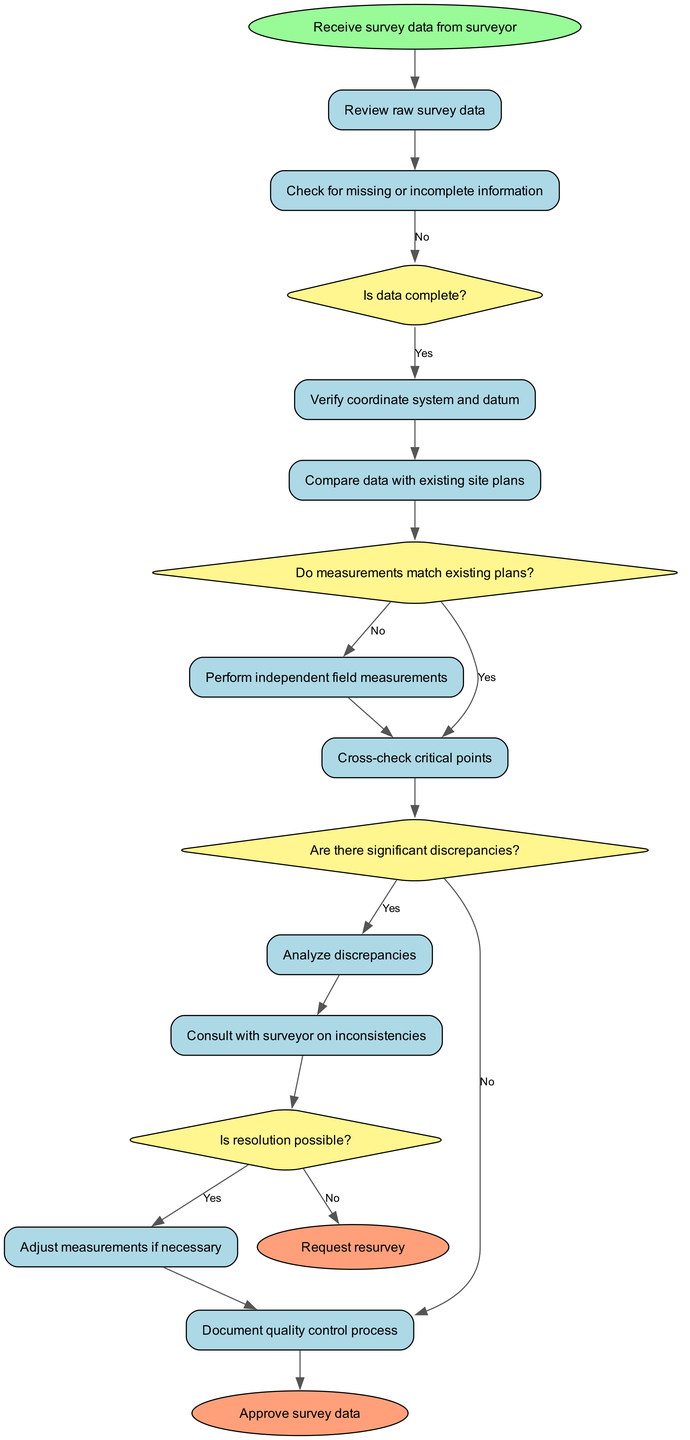What is the first activity after receiving survey data? The first activity listed after the "Receive survey data from surveyor" start node is "Review raw survey data." This is directly connected to the start node, indicating it is the next step in the process.
Answer: Review raw survey data How many decisions are present in the diagram? There are four decision nodes in the diagram: "Is data complete?", "Do measurements match existing plans?", "Are there significant discrepancies?", and "Is resolution possible?". Each of these diamonds represents a decision point.
Answer: 4 What do you do if there are significant discrepancies? If there are significant discrepancies, the flow leads to the "Request resurvey" end node. This indicates that instead of proceeding, the appropriate action is to request a resurvey to address the discrepancies.
Answer: Request resurvey Which activity follows "Analyze discrepancies"? After "Analyze discrepancies", the next activity is "Consult with surveyor on inconsistencies." This direct connection indicates that once discrepancies are analyzed, consultation is required.
Answer: Consult with surveyor on inconsistencies What is the outcome if adjustments are made successfully? If adjustments are made successfully after consulting with the surveyor, the process culminates in the "Approve survey data" end node. This indicates that successful adjustments lead to the data being approved.
Answer: Approve survey data What is the decision made before performing independent field measurements? Before performing independent field measurements, the decision made is "Do measurements match existing plans?" If the answer is "No," the process leads directly to performing the independent measurements.
Answer: Do measurements match existing plans? What happens if the data is not complete? If the data is not complete, the flow results in the "No" path leading to the end condition of "Request resurvey", suggesting that incomplete data necessitates requesting a new survey.
Answer: Request resurvey In which flow do "Minor adjustments" appear? The "Minor adjustments" flow appears after the decision "Are there significant discrepancies?". If the discrepancies are minor, the process continues, but if they are significant, it will follow a different path.
Answer: Are there significant discrepancies? What does the "Document quality control process" activity indicate? The activity "Document quality control process" indicates that it is one of the final steps to ensure that all measures taken during the quality control process are properly recorded, finishing the current validation step before approval.
Answer: Document quality control process 